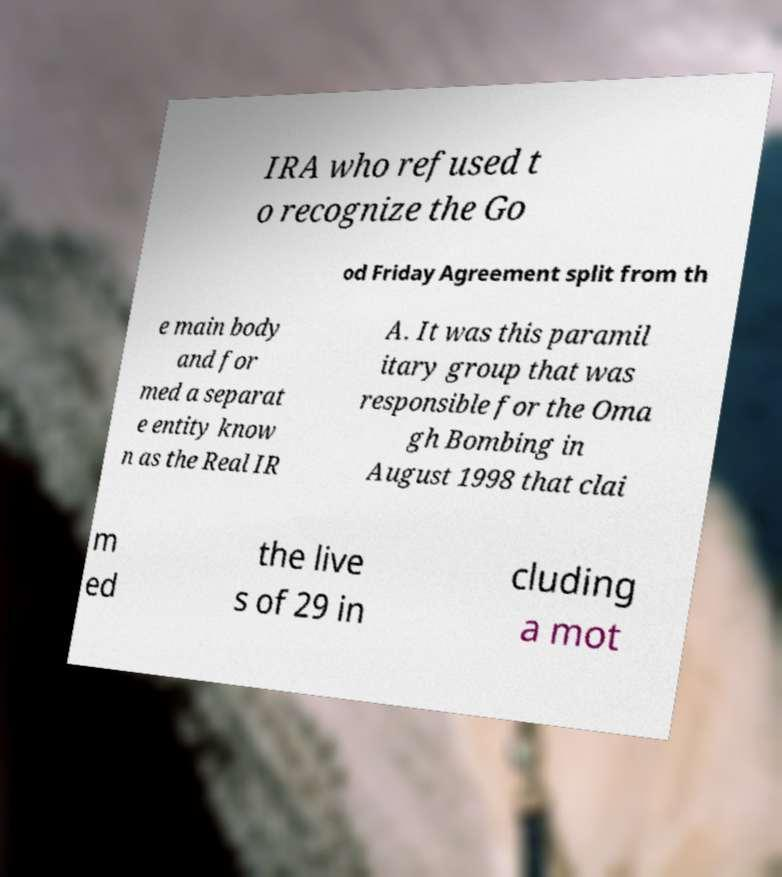Can you read and provide the text displayed in the image?This photo seems to have some interesting text. Can you extract and type it out for me? IRA who refused t o recognize the Go od Friday Agreement split from th e main body and for med a separat e entity know n as the Real IR A. It was this paramil itary group that was responsible for the Oma gh Bombing in August 1998 that clai m ed the live s of 29 in cluding a mot 